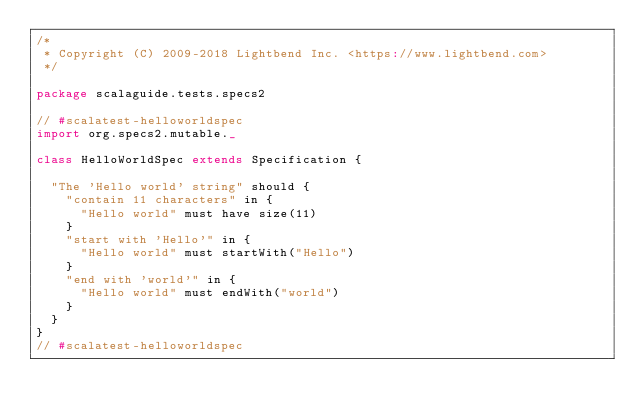Convert code to text. <code><loc_0><loc_0><loc_500><loc_500><_Scala_>/*
 * Copyright (C) 2009-2018 Lightbend Inc. <https://www.lightbend.com>
 */

package scalaguide.tests.specs2

// #scalatest-helloworldspec
import org.specs2.mutable._

class HelloWorldSpec extends Specification {

  "The 'Hello world' string" should {
    "contain 11 characters" in {
      "Hello world" must have size(11)
    }
    "start with 'Hello'" in {
      "Hello world" must startWith("Hello")
    }
    "end with 'world'" in {
      "Hello world" must endWith("world")
    }
  }
}
// #scalatest-helloworldspec
</code> 